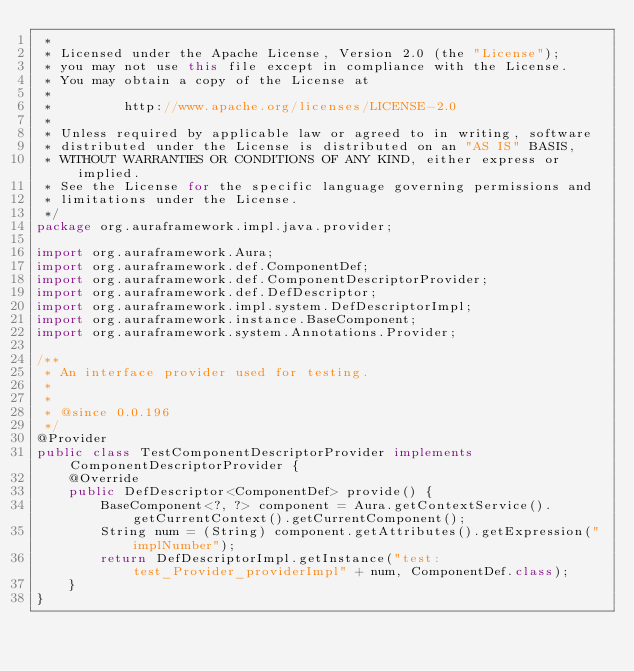<code> <loc_0><loc_0><loc_500><loc_500><_Java_> *
 * Licensed under the Apache License, Version 2.0 (the "License");
 * you may not use this file except in compliance with the License.
 * You may obtain a copy of the License at
 *
 *         http://www.apache.org/licenses/LICENSE-2.0
 *
 * Unless required by applicable law or agreed to in writing, software
 * distributed under the License is distributed on an "AS IS" BASIS,
 * WITHOUT WARRANTIES OR CONDITIONS OF ANY KIND, either express or implied.
 * See the License for the specific language governing permissions and
 * limitations under the License.
 */
package org.auraframework.impl.java.provider;

import org.auraframework.Aura;
import org.auraframework.def.ComponentDef;
import org.auraframework.def.ComponentDescriptorProvider;
import org.auraframework.def.DefDescriptor;
import org.auraframework.impl.system.DefDescriptorImpl;
import org.auraframework.instance.BaseComponent;
import org.auraframework.system.Annotations.Provider;

/**
 * An interface provider used for testing.
 * 
 * 
 * @since 0.0.196
 */
@Provider
public class TestComponentDescriptorProvider implements ComponentDescriptorProvider {
    @Override
    public DefDescriptor<ComponentDef> provide() {
        BaseComponent<?, ?> component = Aura.getContextService().getCurrentContext().getCurrentComponent();
        String num = (String) component.getAttributes().getExpression("implNumber");
        return DefDescriptorImpl.getInstance("test:test_Provider_providerImpl" + num, ComponentDef.class);
    }
}
</code> 